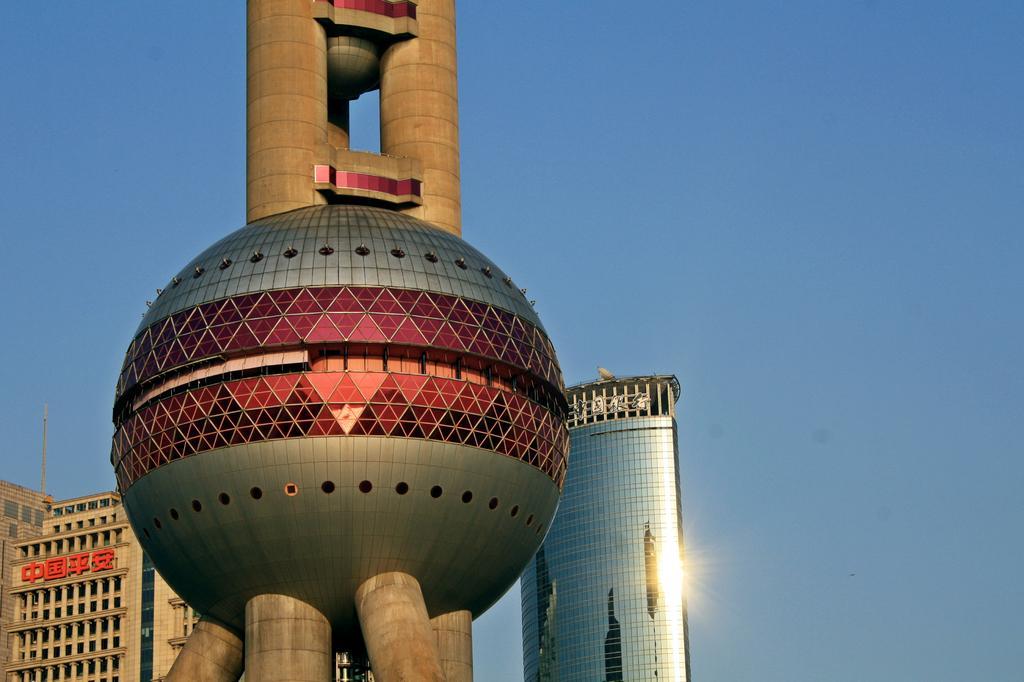How would you summarize this image in a sentence or two? In this picture we can see ball shaped building. Beside that we can see buildings and skyscraper. In the bottom right we can see the sun in the reflection. At the top there is a sky. On the left there is a tower at the top of the building. 